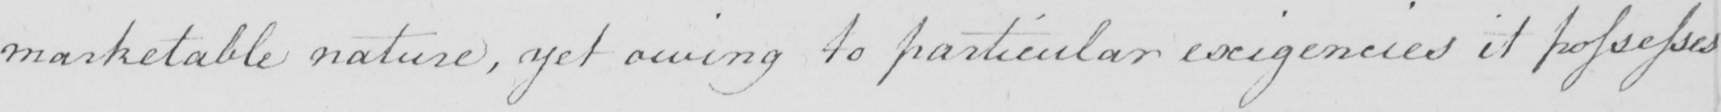What does this handwritten line say? marketable nature , yet owing to particular exigencies it possesses 